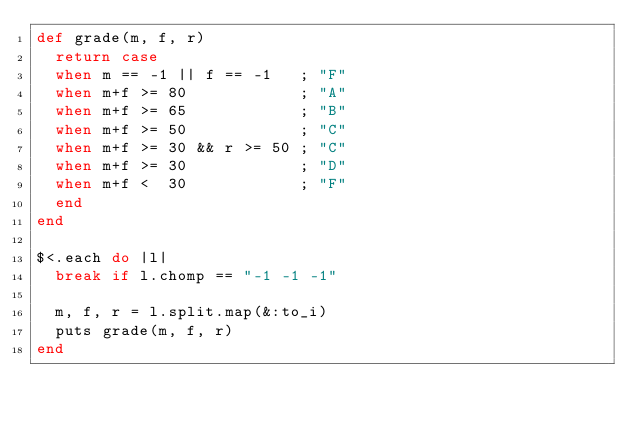<code> <loc_0><loc_0><loc_500><loc_500><_Ruby_>def grade(m, f, r)
  return case
  when m == -1 || f == -1   ; "F"
  when m+f >= 80            ; "A"
  when m+f >= 65            ; "B"
  when m+f >= 50            ; "C"
  when m+f >= 30 && r >= 50 ; "C"
  when m+f >= 30            ; "D"
  when m+f <  30            ; "F"
  end
end

$<.each do |l|
  break if l.chomp == "-1 -1 -1"

  m, f, r = l.split.map(&:to_i)
  puts grade(m, f, r)
end</code> 